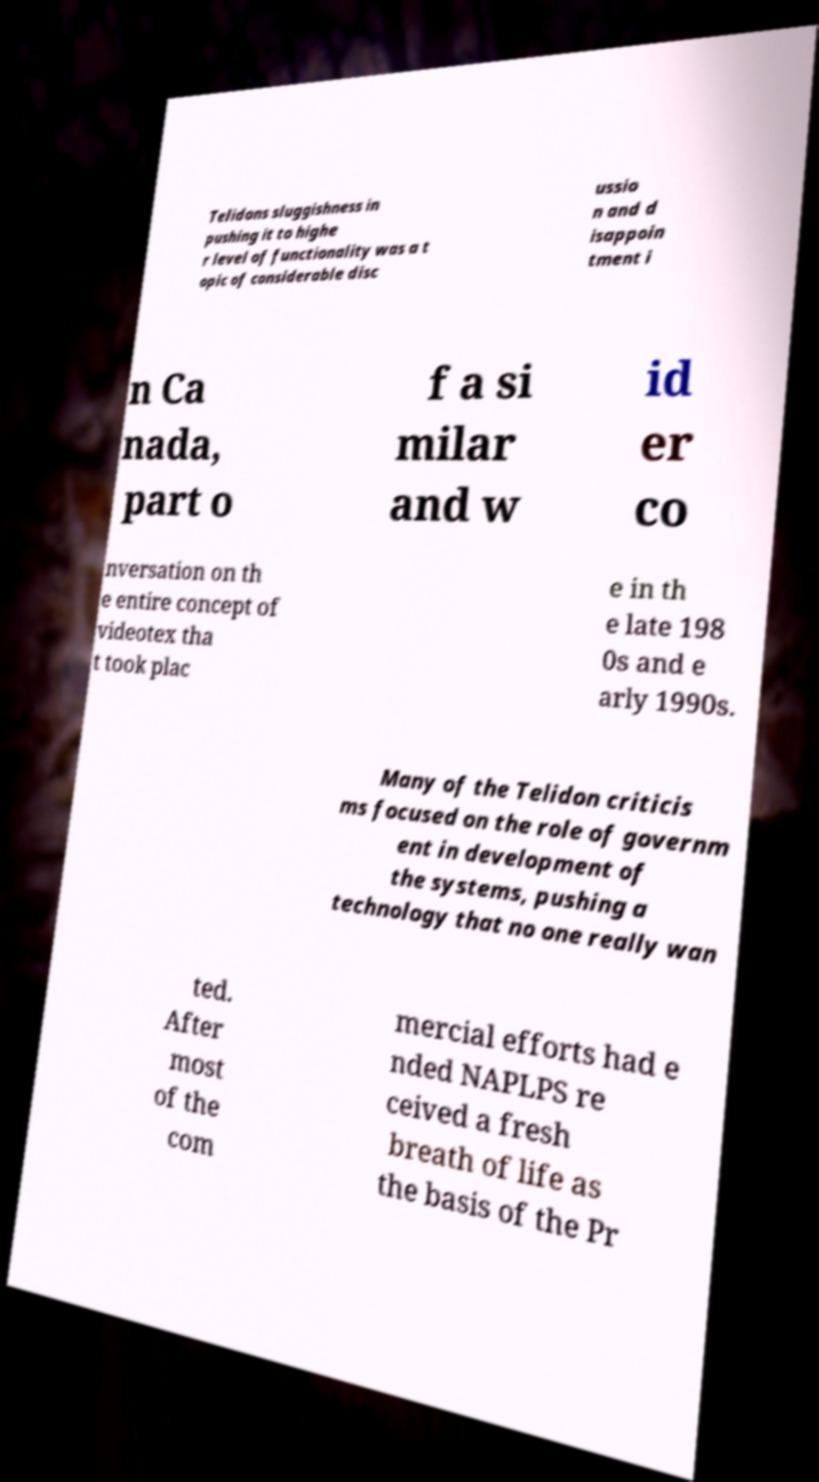There's text embedded in this image that I need extracted. Can you transcribe it verbatim? Telidons sluggishness in pushing it to highe r level of functionality was a t opic of considerable disc ussio n and d isappoin tment i n Ca nada, part o f a si milar and w id er co nversation on th e entire concept of videotex tha t took plac e in th e late 198 0s and e arly 1990s. Many of the Telidon criticis ms focused on the role of governm ent in development of the systems, pushing a technology that no one really wan ted. After most of the com mercial efforts had e nded NAPLPS re ceived a fresh breath of life as the basis of the Pr 